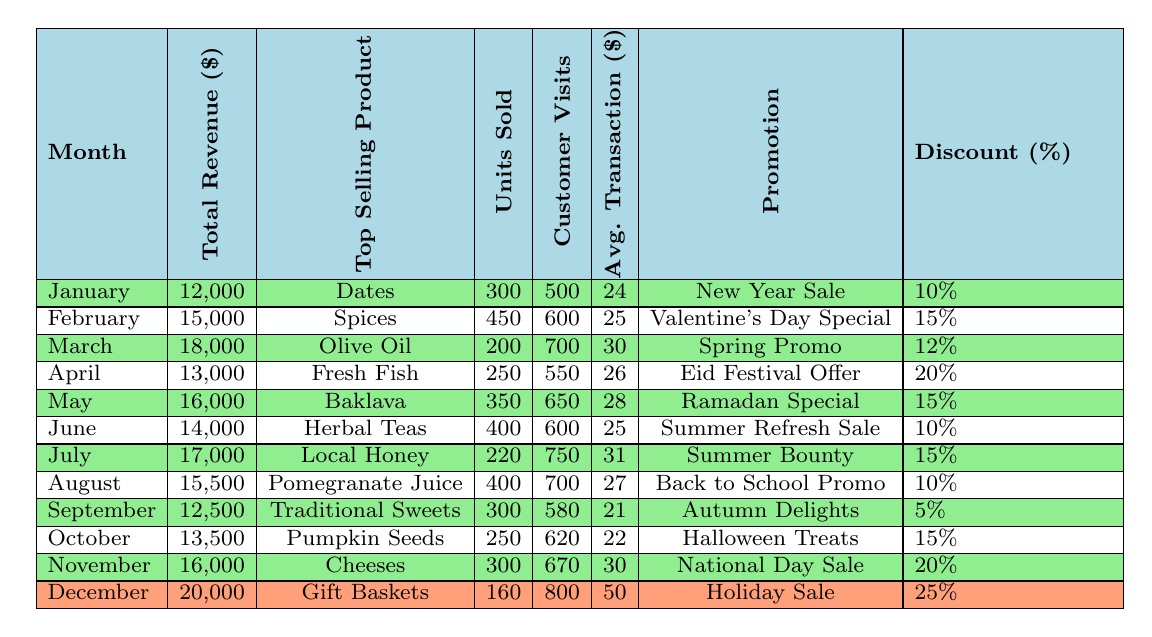What was the total revenue for July? The table shows that the total revenue for July is listed as 17,000.
Answer: 17,000 Which month had the highest average transaction value? By comparing the average transaction values listed for each month, December has the highest value at 50.
Answer: December How many customer visits were recorded in November? Referring to the table, the number of customer visits in November is stated as 670.
Answer: 670 What is the difference in total revenue between January and March? The total revenue for January is 12,000, and for March, it is 18,000. The difference is 18,000 - 12,000 = 6,000.
Answer: 6,000 Was the promotion offered in February more generous than that in June? The promotion discount in February is 15%, while in June, it is 10%. Since 15% is greater than 10%, the answer is yes.
Answer: Yes Which month had the lowest total revenue? Upon reviewing the total revenues in the table, January has the lowest revenue of 12,000.
Answer: January What is the total revenue generated in the first half of the year (January to June)? The total revenue for the first half is 12,000 (Jan) + 15,000 (Feb) + 18,000 (Mar) + 13,000 (Apr) + 16,000 (May) + 14,000 (Jun) = 88,000.
Answer: 88,000 Which product sold the most units in April? According to the table, the top-selling product in April is Fresh Fish, with 250 units sold.
Answer: Fresh Fish Did customer visits increase or decrease from March to April? In March, there were 700 customer visits, and in April, there were 550. Since 550 is less than 700, the visits decreased.
Answer: Decreased What is the average revenue per customer visit in August? In August, the total revenue is 15,500, and the customer visits are 700. The average revenue per visit is 15,500/700 = 22.14 (approximately).
Answer: 22.14 What was the highest discount offered on promotions throughout the year? The table indicates that December had the highest discount of 25% for the Holiday Sale.
Answer: 25% How many total units of Traditional Sweets were sold in September? The table specifies that 300 units of Traditional Sweets were sold in September.
Answer: 300 What is the average total revenue over the entire year? The total revenues from the months are: 12,000 + 15,000 + 18,000 + 13,000 + 16,000 + 14,000 + 17,000 + 15,500 + 12,500 + 13,500 + 16,000 + 20,000 =  180,000. With 12 months, the average is 180,000 / 12 = 15,000.
Answer: 15,000 Which month had the least number of units sold? The table shows that March had the least number of units sold with 200 units of Olive Oil sold.
Answer: March 